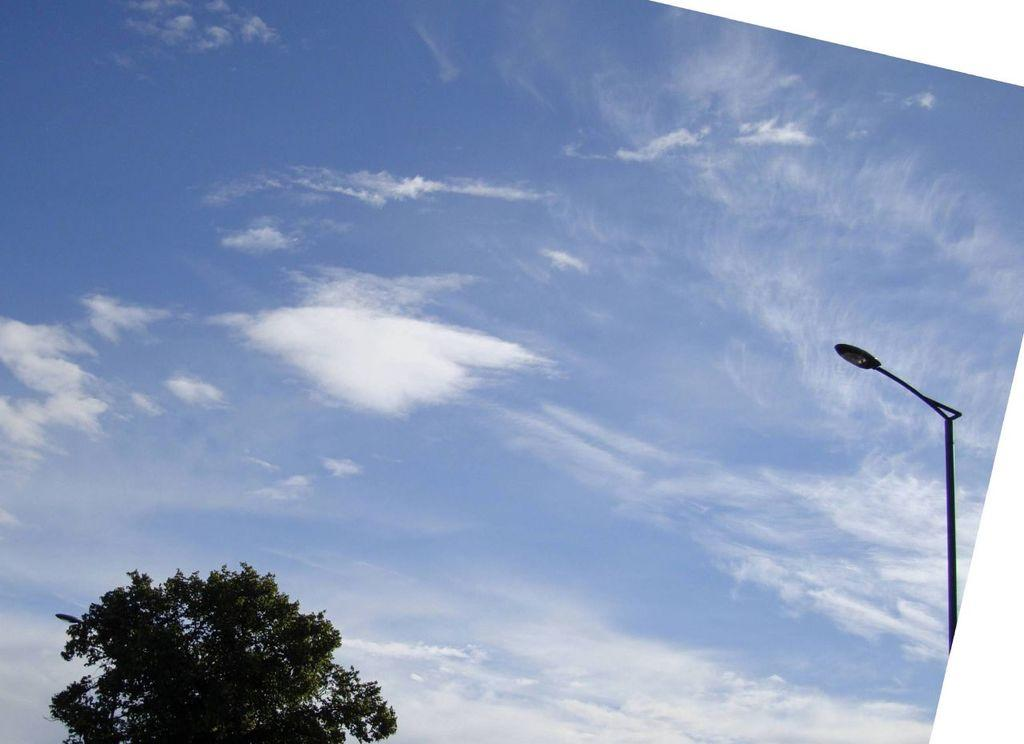What type of natural element is present in the image? There is a tree in the image. What artificial element can be seen in the image? There is a street light in the image. What other man-made object is visible in the image? There is a pole in the image. How would you describe the weather in the image? The sky is cloudy in the image. Can you see any soda cans floating in space in the image? There is no reference to soda cans or space in the image; it features a tree, a street light, a pole, and a cloudy sky. 